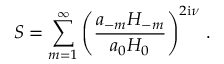Convert formula to latex. <formula><loc_0><loc_0><loc_500><loc_500>S = \sum _ { m = 1 } ^ { \infty } \left ( \frac { a _ { - m } H _ { - m } } { a _ { 0 } H _ { 0 } } \right ) ^ { 2 i \nu } \, .</formula> 